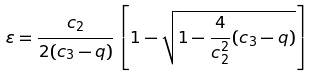Convert formula to latex. <formula><loc_0><loc_0><loc_500><loc_500>\varepsilon = \frac { c _ { 2 } } { 2 ( c _ { 3 } - q ) } \left [ 1 - \sqrt { 1 - \frac { 4 } { c _ { 2 } ^ { 2 } } ( c _ { 3 } - q ) } \right ]</formula> 